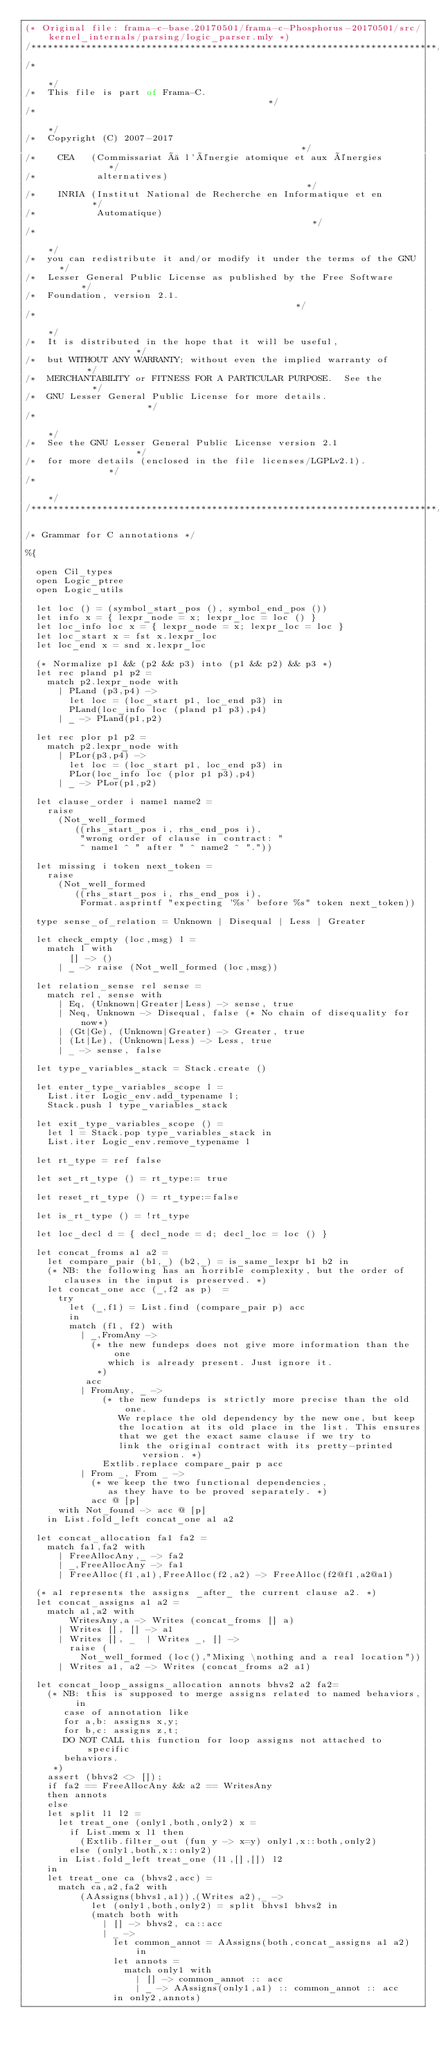<code> <loc_0><loc_0><loc_500><loc_500><_OCaml_>(* Original file: frama-c-base.20170501/frama-c-Phosphorus-20170501/src/kernel_internals/parsing/logic_parser.mly *)
/**************************************************************************/
/*                                                                        */
/*  This file is part of Frama-C.                                         */
/*                                                                        */
/*  Copyright (C) 2007-2017                                               */
/*    CEA   (Commissariat à l'énergie atomique et aux énergies            */
/*           alternatives)                                                */
/*    INRIA (Institut National de Recherche en Informatique et en         */
/*           Automatique)                                                 */
/*                                                                        */
/*  you can redistribute it and/or modify it under the terms of the GNU   */
/*  Lesser General Public License as published by the Free Software       */
/*  Foundation, version 2.1.                                              */
/*                                                                        */
/*  It is distributed in the hope that it will be useful,                 */
/*  but WITHOUT ANY WARRANTY; without even the implied warranty of        */
/*  MERCHANTABILITY or FITNESS FOR A PARTICULAR PURPOSE.  See the         */
/*  GNU Lesser General Public License for more details.                   */
/*                                                                        */
/*  See the GNU Lesser General Public License version 2.1                 */
/*  for more details (enclosed in the file licenses/LGPLv2.1).            */
/*                                                                        */
/**************************************************************************/

/* Grammar for C annotations */

%{

  open Cil_types
  open Logic_ptree
  open Logic_utils

  let loc () = (symbol_start_pos (), symbol_end_pos ())
  let info x = { lexpr_node = x; lexpr_loc = loc () }
  let loc_info loc x = { lexpr_node = x; lexpr_loc = loc }
  let loc_start x = fst x.lexpr_loc
  let loc_end x = snd x.lexpr_loc

  (* Normalize p1 && (p2 && p3) into (p1 && p2) && p3 *)
  let rec pland p1 p2 =
    match p2.lexpr_node with
      | PLand (p3,p4) ->
        let loc = (loc_start p1, loc_end p3) in
        PLand(loc_info loc (pland p1 p3),p4)
      | _ -> PLand(p1,p2)

  let rec plor p1 p2 =
    match p2.lexpr_node with
      | PLor(p3,p4) ->
        let loc = (loc_start p1, loc_end p3) in
        PLor(loc_info loc (plor p1 p3),p4)
      | _ -> PLor(p1,p2)

  let clause_order i name1 name2 =
    raise
      (Not_well_formed
         ((rhs_start_pos i, rhs_end_pos i),
          "wrong order of clause in contract: "
          ^ name1 ^ " after " ^ name2 ^ "."))

  let missing i token next_token =
    raise
      (Not_well_formed
         ((rhs_start_pos i, rhs_end_pos i),
          Format.asprintf "expecting '%s' before %s" token next_token))

  type sense_of_relation = Unknown | Disequal | Less | Greater

  let check_empty (loc,msg) l =
    match l with
        [] -> ()
      | _ -> raise (Not_well_formed (loc,msg))

  let relation_sense rel sense =
    match rel, sense with
      | Eq, (Unknown|Greater|Less) -> sense, true
      | Neq, Unknown -> Disequal, false (* No chain of disequality for now*)
      | (Gt|Ge), (Unknown|Greater) -> Greater, true
      | (Lt|Le), (Unknown|Less) -> Less, true
      | _ -> sense, false

  let type_variables_stack = Stack.create ()

  let enter_type_variables_scope l =
    List.iter Logic_env.add_typename l;
    Stack.push l type_variables_stack

  let exit_type_variables_scope () =
    let l = Stack.pop type_variables_stack in
    List.iter Logic_env.remove_typename l

  let rt_type = ref false

  let set_rt_type () = rt_type:= true

  let reset_rt_type () = rt_type:=false

  let is_rt_type () = !rt_type

  let loc_decl d = { decl_node = d; decl_loc = loc () }

  let concat_froms a1 a2 =
    let compare_pair (b1,_) (b2,_) = is_same_lexpr b1 b2 in
    (* NB: the following has an horrible complexity, but the order of 
       clauses in the input is preserved. *)
    let concat_one acc (_,f2 as p)  =
      try
        let (_,f1) = List.find (compare_pair p) acc
        in
        match (f1, f2) with
          | _,FromAny -> 
            (* the new fundeps does not give more information than the one
               which is already present. Just ignore it.
             *)
           acc
          | FromAny, _ ->
              (* the new fundeps is strictly more precise than the old one.
                 We replace the old dependency by the new one, but keep
                 the location at its old place in the list. This ensures
                 that we get the exact same clause if we try to 
                 link the original contract with its pretty-printed version. *)
              Extlib.replace compare_pair p acc
          | From _, From _ -> 
            (* we keep the two functional dependencies, 
               as they have to be proved separately. *)
            acc @ [p]
      with Not_found -> acc @ [p]
    in List.fold_left concat_one a1 a2

  let concat_allocation fa1 fa2 =
    match fa1,fa2 with
      | FreeAllocAny,_ -> fa2
      | _,FreeAllocAny -> fa1
      | FreeAlloc(f1,a1),FreeAlloc(f2,a2) -> FreeAlloc(f2@f1,a2@a1)
 
  (* a1 represents the assigns _after_ the current clause a2. *)
  let concat_assigns a1 a2 =
    match a1,a2 with
        WritesAny,a -> Writes (concat_froms [] a)
      | Writes [], [] -> a1
      | Writes [], _  | Writes _, [] ->
        raise (
          Not_well_formed (loc(),"Mixing \nothing and a real location"))
      | Writes a1, a2 -> Writes (concat_froms a2 a1)

  let concat_loop_assigns_allocation annots bhvs2 a2 fa2=
    (* NB: this is supposed to merge assigns related to named behaviors, in 
       case of annotation like
       for a,b: assigns x,y;
       for b,c: assigns z,t;
       DO NOT CALL this function for loop assigns not attached to specific 
       behaviors. 
     *)
    assert (bhvs2 <> []);
    if fa2 == FreeAllocAny && a2 == WritesAny 
    then annots
    else 
    let split l1 l2 =
      let treat_one (only1,both,only2) x =
        if List.mem x l1 then
          (Extlib.filter_out (fun y -> x=y) only1,x::both,only2)
        else (only1,both,x::only2)
      in List.fold_left treat_one (l1,[],[]) l2
    in
    let treat_one ca (bhvs2,acc) =
      match ca,a2,fa2 with
          (AAssigns(bhvs1,a1)),(Writes a2),_ ->
            let (only1,both,only2) = split bhvs1 bhvs2 in
            (match both with
              | [] -> bhvs2, ca::acc
              | _ ->
                let common_annot = AAssigns(both,concat_assigns a1 a2) in
                let annots =
                  match only1 with
                    | [] -> common_annot :: acc
                    | _ -> AAssigns(only1,a1) :: common_annot :: acc
                in only2,annots)</code> 